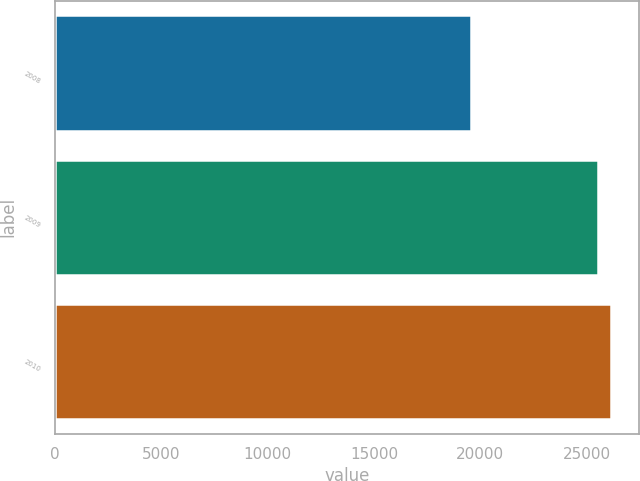Convert chart to OTSL. <chart><loc_0><loc_0><loc_500><loc_500><bar_chart><fcel>2008<fcel>2009<fcel>2010<nl><fcel>19562<fcel>25529<fcel>26160.2<nl></chart> 